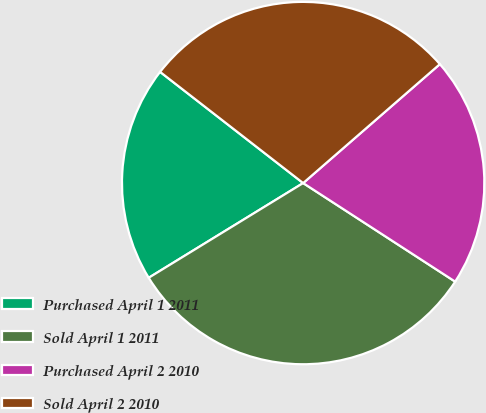Convert chart to OTSL. <chart><loc_0><loc_0><loc_500><loc_500><pie_chart><fcel>Purchased April 1 2011<fcel>Sold April 1 2011<fcel>Purchased April 2 2010<fcel>Sold April 2 2010<nl><fcel>19.27%<fcel>32.09%<fcel>20.55%<fcel>28.09%<nl></chart> 